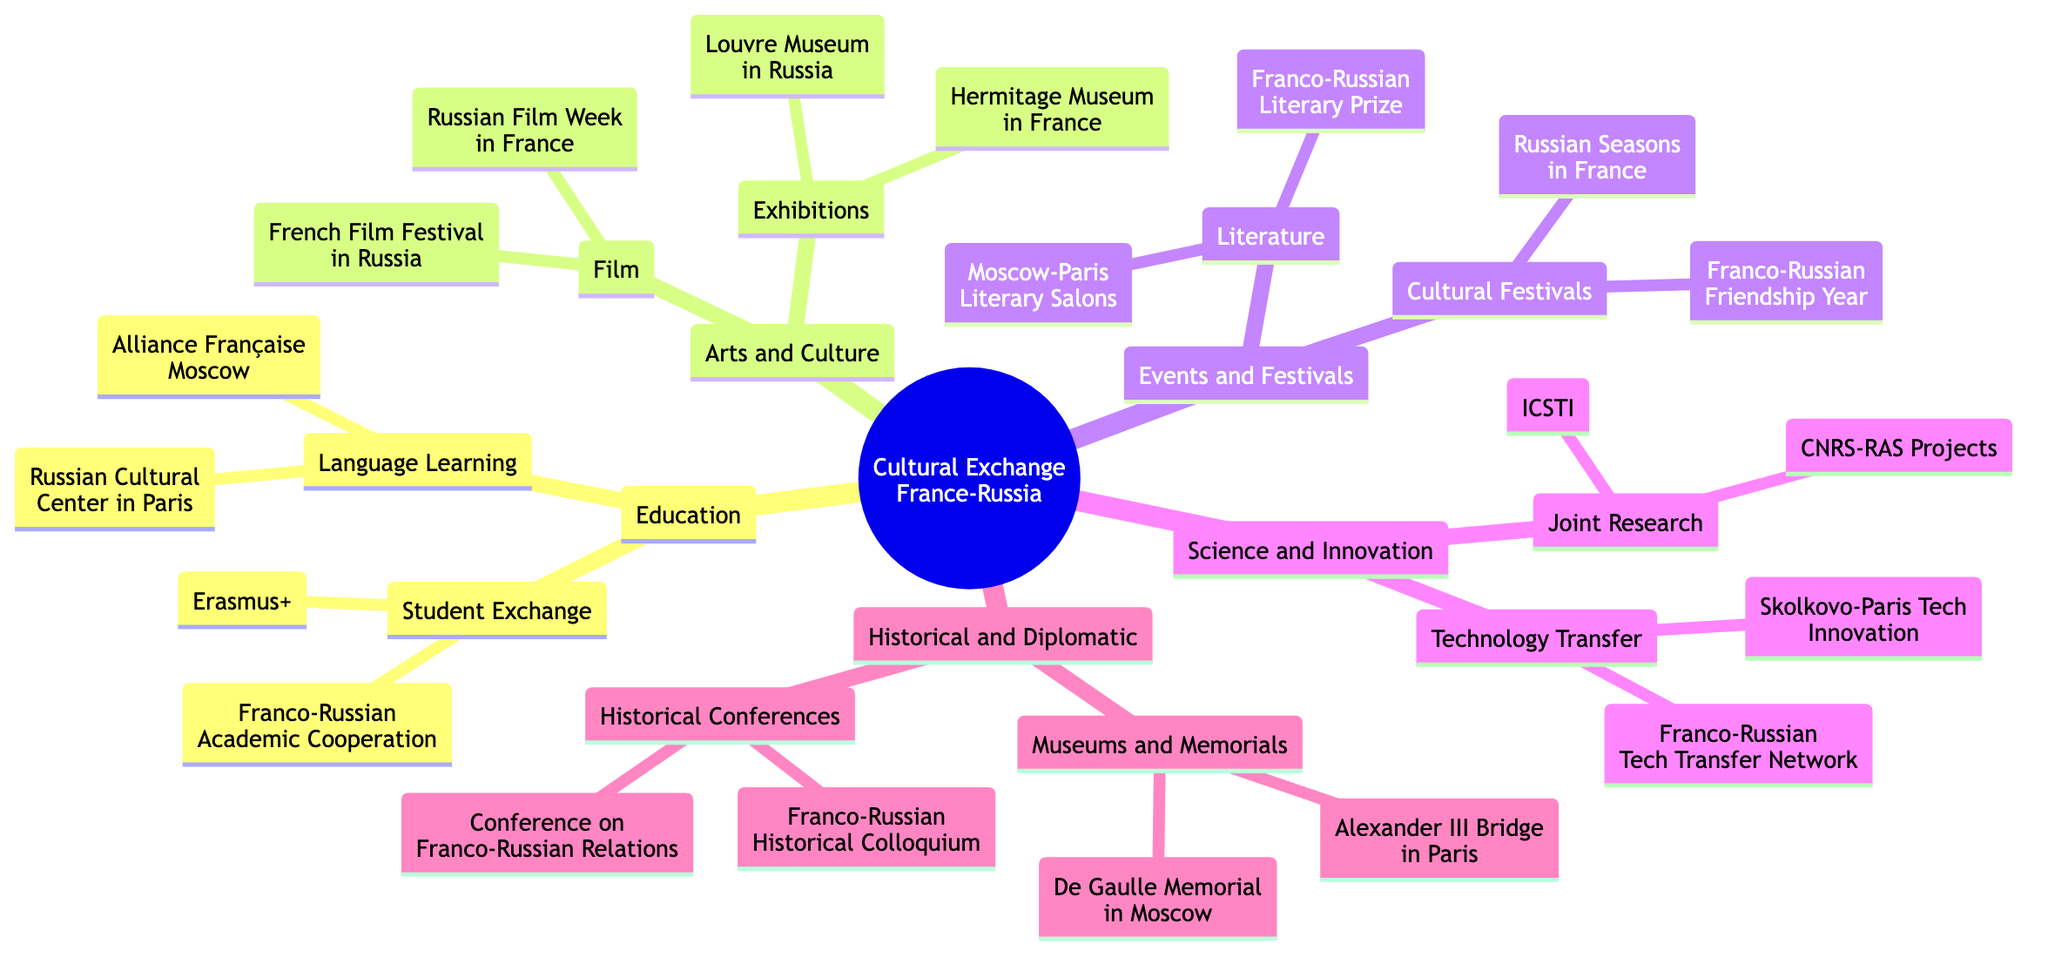What cultural exchange program is specific to student exchanges? The diagram specifies two programs under "Student Exchange Programs" which are "Erasmus+" and "Franco-Russian Academic Cooperation Program". By looking under the "Education" section, we can see these programs listed.
Answer: Erasmus+, Franco-Russian Academic Cooperation Program What type of language learning institutions are involved in the cultural exchange? The diagram lists two language learning institutions: "Alliance Française Moscow" and "Russian Cultural Center in Paris". These are the components under "Language Learning" in the "Education" section.
Answer: Alliance Française Moscow, Russian Cultural Center in Paris How many main categories are there in the cultural exchange programs? The main categories as per the diagram are five: "Education," "Arts and Culture," "Events and Festivals," "Science and Innovation," and "Historical and Diplomatic Ties." This counts the main branches stemming from the root node.
Answer: 5 What are the two types of events featured in the cultural festivals category? The diagram indicates two events under "Cultural Festivals": "Franco-Russian Friendship Year Events" and "Russian Seasons in France". This information is available under the "Events and Festivals" section.
Answer: Franco-Russian Friendship Year Events, Russian Seasons in France How do the exhibitions relate to art and culture in the context of France and Russia? The diagram shows that under "Arts and Culture," the "Exhibitions" category includes "Hermitage Museum Exhibitions in France" and "Louvre Museum Exhibitions in Russia." This demonstrates the cultural connection through significant art institutions in both countries.
Answer: Hermitage Museum Exhibitions in France, Louvre Museum Exhibitions in Russia What is the significance of the General de Gaulle Memorial? The "Museums and Memorials" section in the "Historical and Diplomatic Ties" category indicates that the General de Gaulle Memorial is located in Moscow. This reflects the historical connection between France and Russia, honoring a prominent French figure.
Answer: General de Gaulle Memorial in Moscow Which two organizations are mentioned under Joint Research? The diagram lists "CNRS-RAS Collaborative Projects" and "International Centre for Scientific and Technical Information" under the "Joint Research" section in "Science and Innovation." This shows collaboration in research areas.
Answer: CNRS-RAS Collaborative Projects, International Centre for Scientific and Technical Information What is one of the literature events mentioned in the cultural exchange? The diagram notes the "Franco-Russian Literary Prize" under the "Literature" category in the "Events and Festivals" section. This event highlights the literary collaboration between the two nations.
Answer: Franco-Russian Literary Prize 